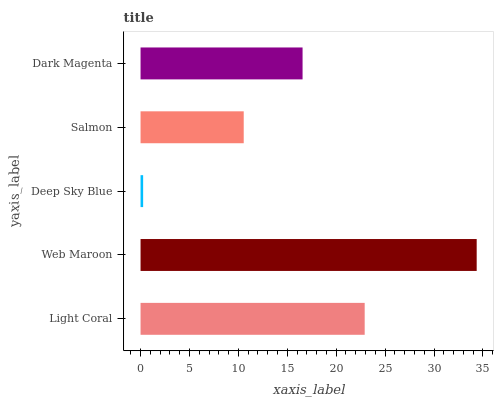Is Deep Sky Blue the minimum?
Answer yes or no. Yes. Is Web Maroon the maximum?
Answer yes or no. Yes. Is Web Maroon the minimum?
Answer yes or no. No. Is Deep Sky Blue the maximum?
Answer yes or no. No. Is Web Maroon greater than Deep Sky Blue?
Answer yes or no. Yes. Is Deep Sky Blue less than Web Maroon?
Answer yes or no. Yes. Is Deep Sky Blue greater than Web Maroon?
Answer yes or no. No. Is Web Maroon less than Deep Sky Blue?
Answer yes or no. No. Is Dark Magenta the high median?
Answer yes or no. Yes. Is Dark Magenta the low median?
Answer yes or no. Yes. Is Web Maroon the high median?
Answer yes or no. No. Is Web Maroon the low median?
Answer yes or no. No. 